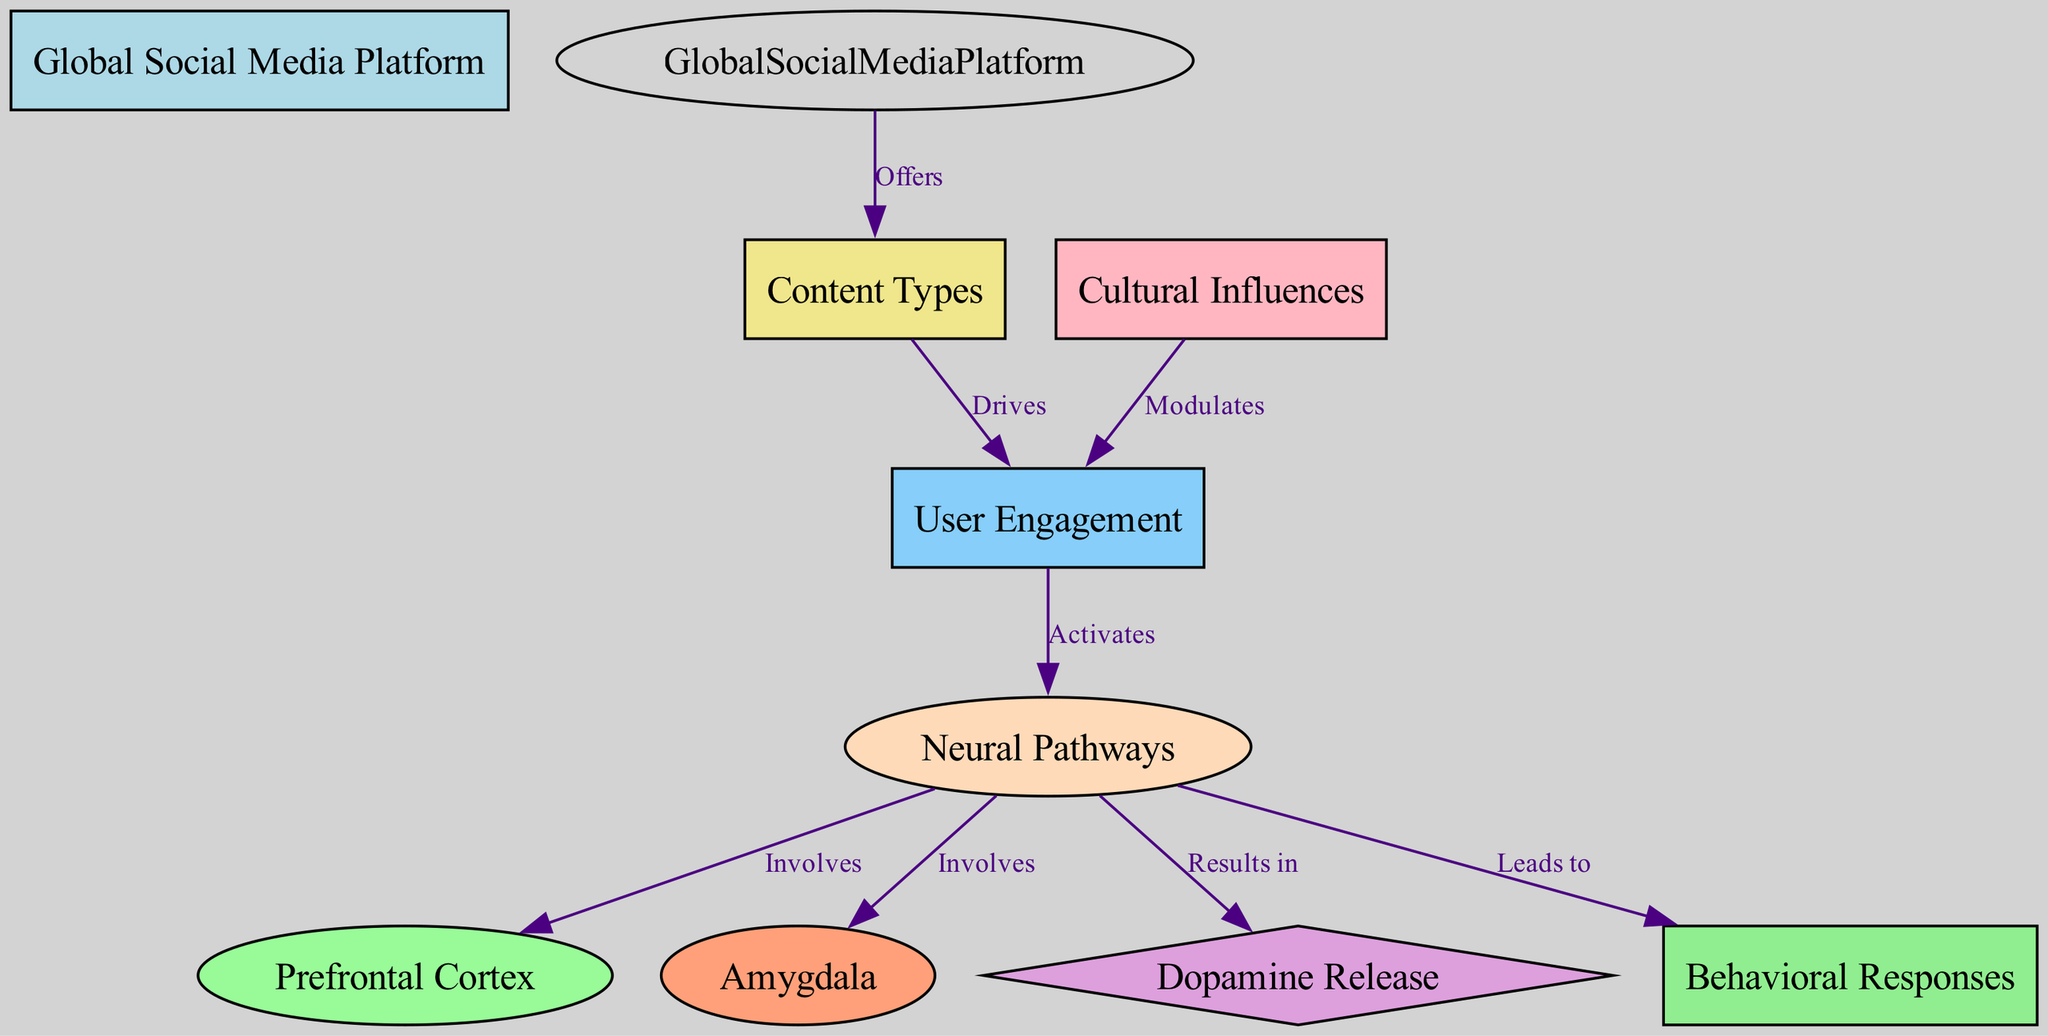What is the total number of nodes in the diagram? The diagram lists the following nodes: Global Social Media Platform, Neural Pathways, Prefrontal Cortex, Amygdala, Dopamine Release, Content Types, User Engagement, Cultural Influences, and Behavioral Responses. Counting these gives a total of 9 nodes.
Answer: 9 Which node receives the label "Leads to"? In the edges of the diagram, the edge that connects Neural Pathways to Behavioral Responses is labeled as "Leads to". Therefore, the node that receives the label "Leads to" is Behavioral Responses.
Answer: Behavioral Responses What two nodes involve the "Neural Pathways"? The edges indicate that both the Prefrontal Cortex and the Amygdala receive connections from Neural Pathways, meaning they are both involved with it as per the diagram.
Answer: Prefrontal Cortex and Amygdala How many relationships are classified under the label "Drives"? The edges indicate a single relationship that connects Content Types to User Engagement with the label "Drives". Thus, there is only one such relationship in the diagram.
Answer: 1 What modulates user engagement according to the diagram? The diagram clearly shows that Cultural Influences has a connecting edge that indicates it modulates User Engagement.
Answer: Cultural Influences Explain how User Engagement leads to Behavioral Responses. User Engagement is depicted in the diagram as activating Neural Pathways, which subsequently leads to Behavioral Responses. The flow can be summarized as follows: User Engagement activates Neural Pathways that lead to changes in Behavior Responses. This demonstrates the chain of influence.
Answer: Neural Pathways Which node is represented by a diamond shape? Among the labeled nodes, Dopamine Release is the only one depicted as a diamond shape, which distinguishes it from other nodes visually.
Answer: Dopamine Release What type of document is this diagram classified under? Given that the focus is on neural pathways and their activation in response to stimuli from social media, this diagram is classified as a Biomedical Diagram.
Answer: Biomedical Diagram 